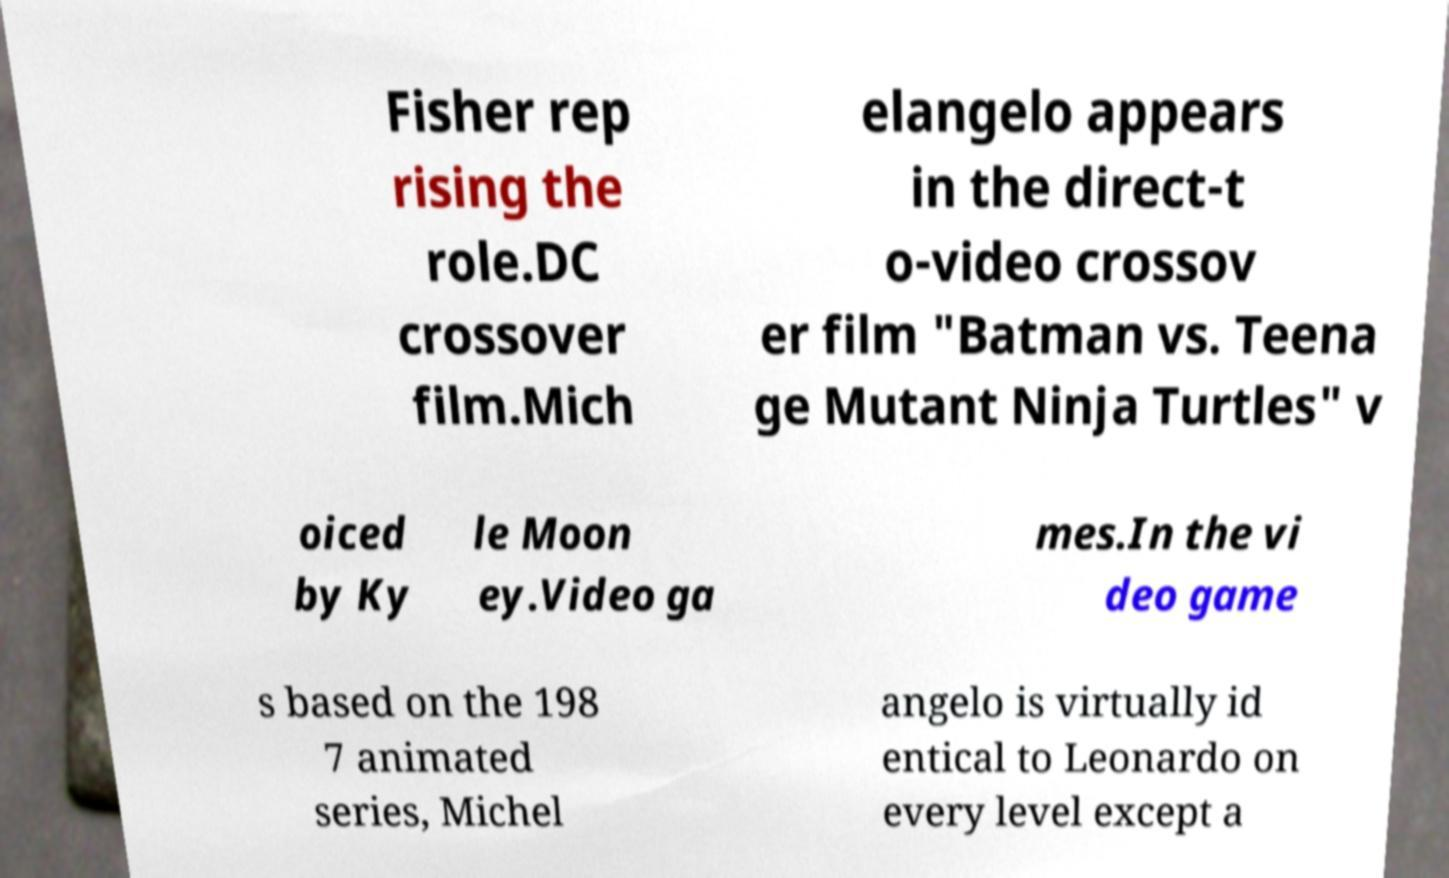For documentation purposes, I need the text within this image transcribed. Could you provide that? Fisher rep rising the role.DC crossover film.Mich elangelo appears in the direct-t o-video crossov er film "Batman vs. Teena ge Mutant Ninja Turtles" v oiced by Ky le Moon ey.Video ga mes.In the vi deo game s based on the 198 7 animated series, Michel angelo is virtually id entical to Leonardo on every level except a 